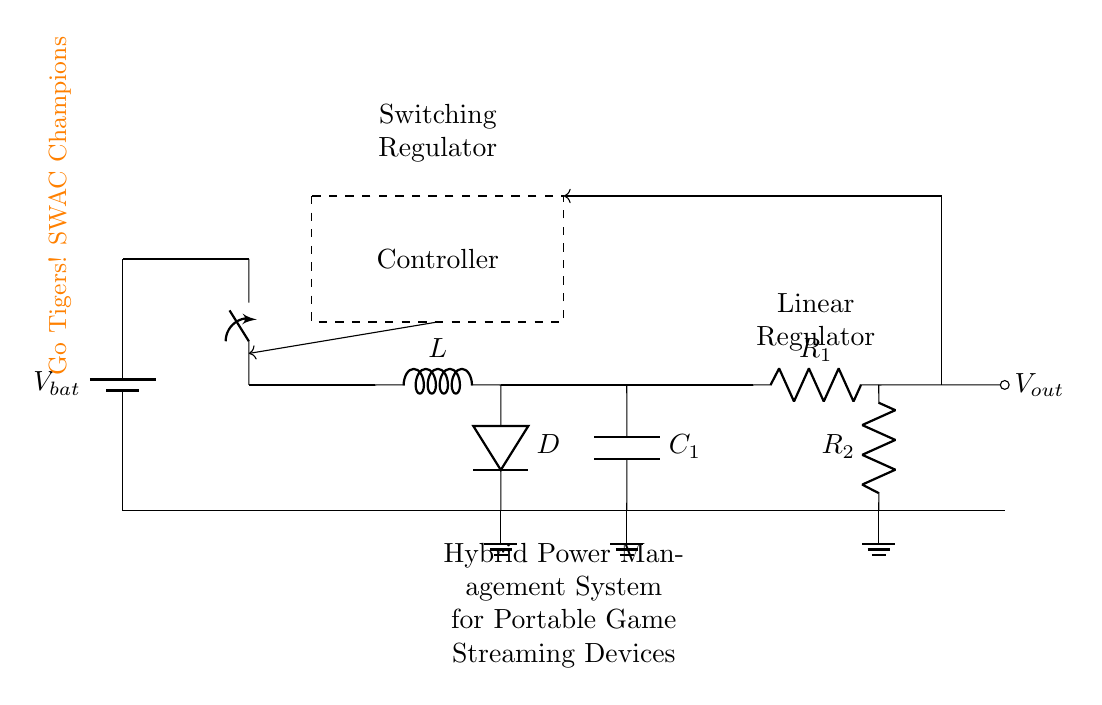What type of regulator is used between the battery and output? The diagram shows both a switching regulator and a linear regulator in the circuit. The switching regulator is the first component after the battery, and the linear regulator follows it before the output.
Answer: Switching and linear What component type is labeled as "D"? The component labeled as "D" is a diode. In a switching regulator, diodes are typically used as output rectifiers to prevent reverse current flow.
Answer: Diode What does the inductor (L) do in this circuit? The inductor in a switching regulator circuit stores energy and helps in converting the input voltage to a lower output voltage through energy transfer. It plays a crucial role in voltage regulation and smoothing the current output.
Answer: Energy storage What is the role of the controller in the hybrid power management system? The controller determines how the power management system responds to changes in load demand and regulates the operation of the switching and linear regulators to ensure stable output voltage and current.
Answer: Regulation How many resistors are present in the circuit? There are two resistors indicated in the diagram, R1 and R2, which are used in association with the linear regulator.
Answer: Two What is the purpose of capacitor C1 in the circuit? Capacitor C1 provides filtering and stabilizing of the voltage output from the switching regulator, smoothing out fluctuations and storing charge to help maintain a steady output.
Answer: Filtering and stabilizing What system is this hybrid circuit designed for? The hybrid power management system is specifically designed for portable game streaming devices, indicating it supports devices requiring efficient and stable power delivery during operation.
Answer: Portable game streaming 